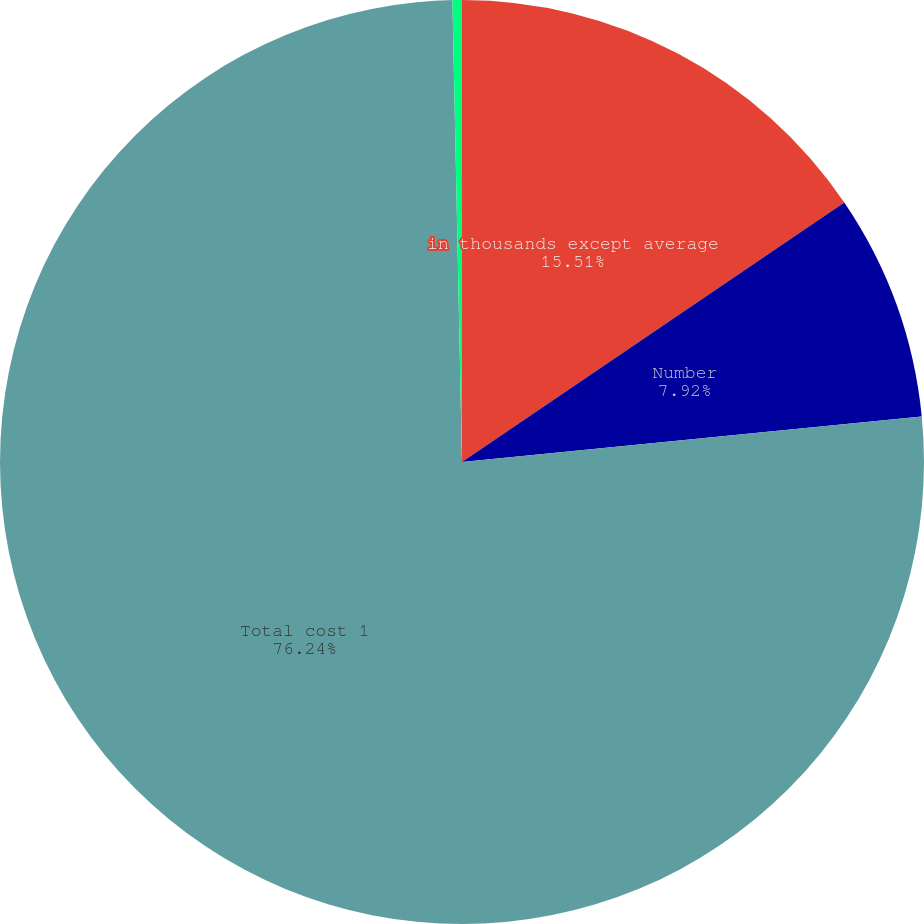Convert chart. <chart><loc_0><loc_0><loc_500><loc_500><pie_chart><fcel>in thousands except average<fcel>Number<fcel>Total cost 1<fcel>Average cost 1 g<nl><fcel>15.51%<fcel>7.92%<fcel>76.23%<fcel>0.33%<nl></chart> 